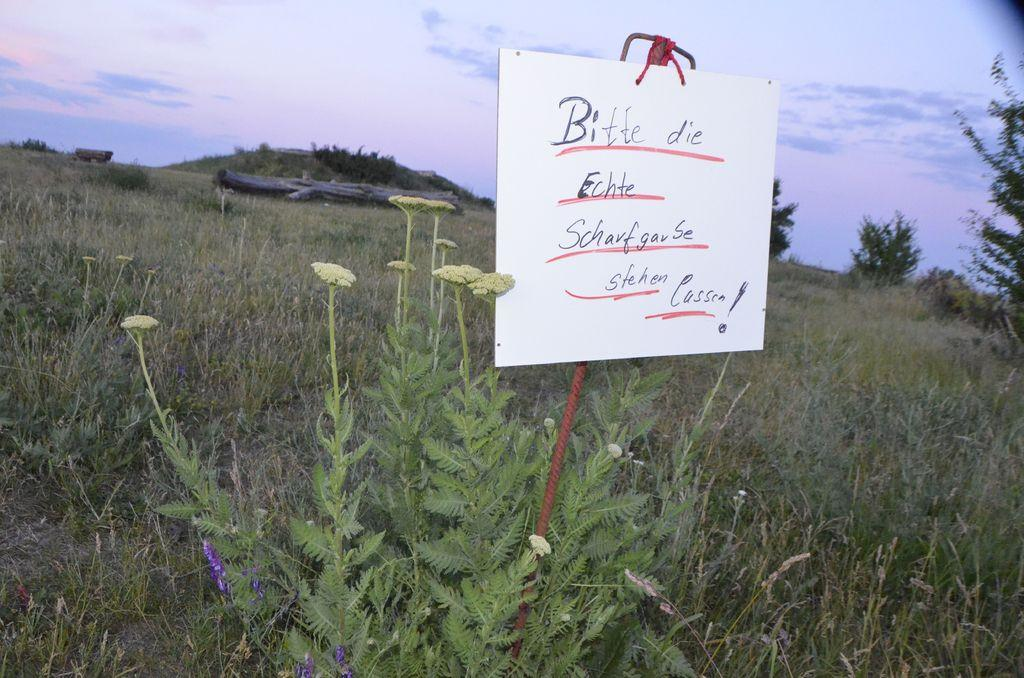What is on the board that is visible in the image? There is text on the board in the image. What can be seen in the background of the image? Sky, mountains, grass, and plants are visible in the background of the image. How many hens are present in the image? There are no hens present in the image. What rule is being enforced by the mountains in the image? The mountains do not enforce any rules; they are a natural geographical feature in the background of the image. 